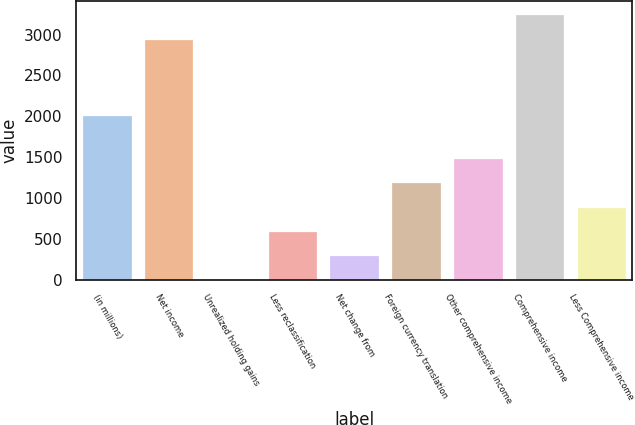<chart> <loc_0><loc_0><loc_500><loc_500><bar_chart><fcel>(in millions)<fcel>Net income<fcel>Unrealized holding gains<fcel>Less reclassification<fcel>Net change from<fcel>Foreign currency translation<fcel>Other comprehensive income<fcel>Comprehensive income<fcel>Less Comprehensive income<nl><fcel>2013<fcel>2951<fcel>4<fcel>598.2<fcel>301.1<fcel>1192.4<fcel>1489.5<fcel>3248.1<fcel>895.3<nl></chart> 